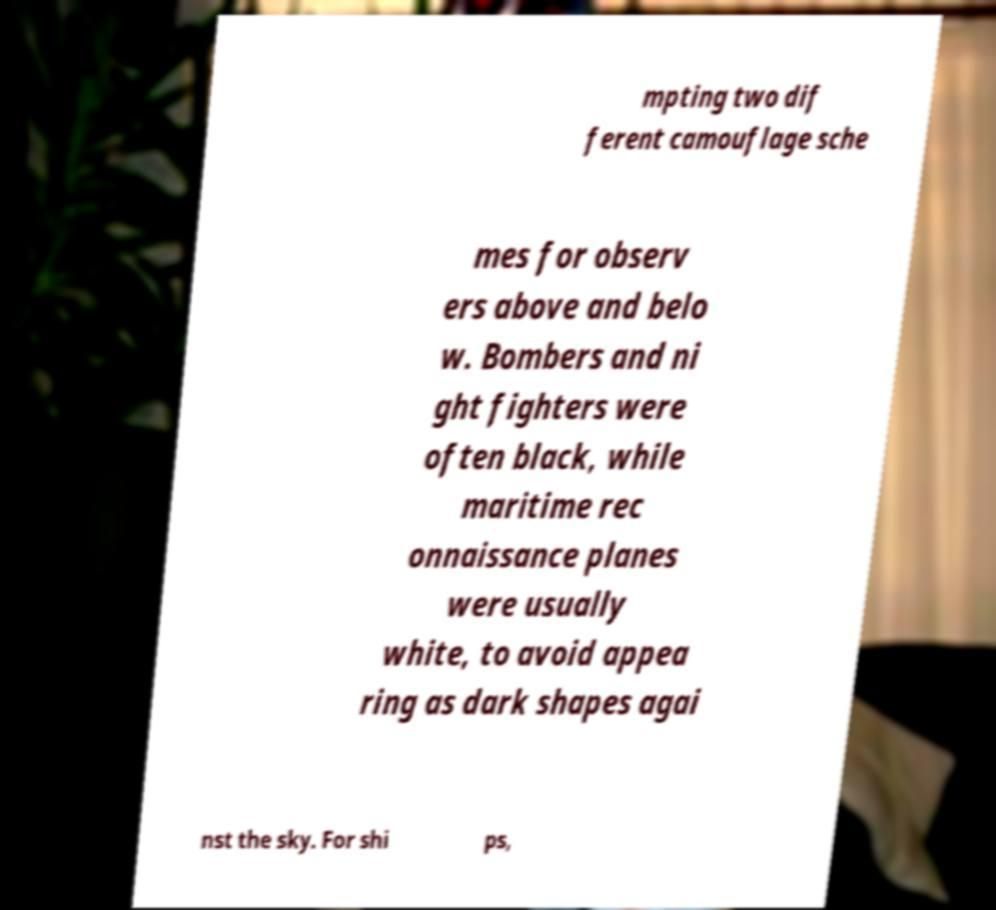Could you extract and type out the text from this image? mpting two dif ferent camouflage sche mes for observ ers above and belo w. Bombers and ni ght fighters were often black, while maritime rec onnaissance planes were usually white, to avoid appea ring as dark shapes agai nst the sky. For shi ps, 